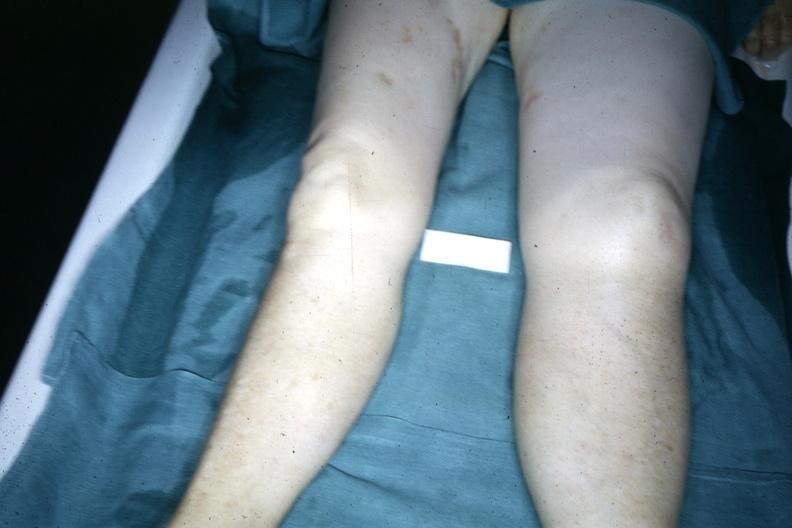why is legs demonstrated with one about twice the size of the other?
Answer the question using a single word or phrase. Due to malignant lymphoma involving lymphatic drainage 